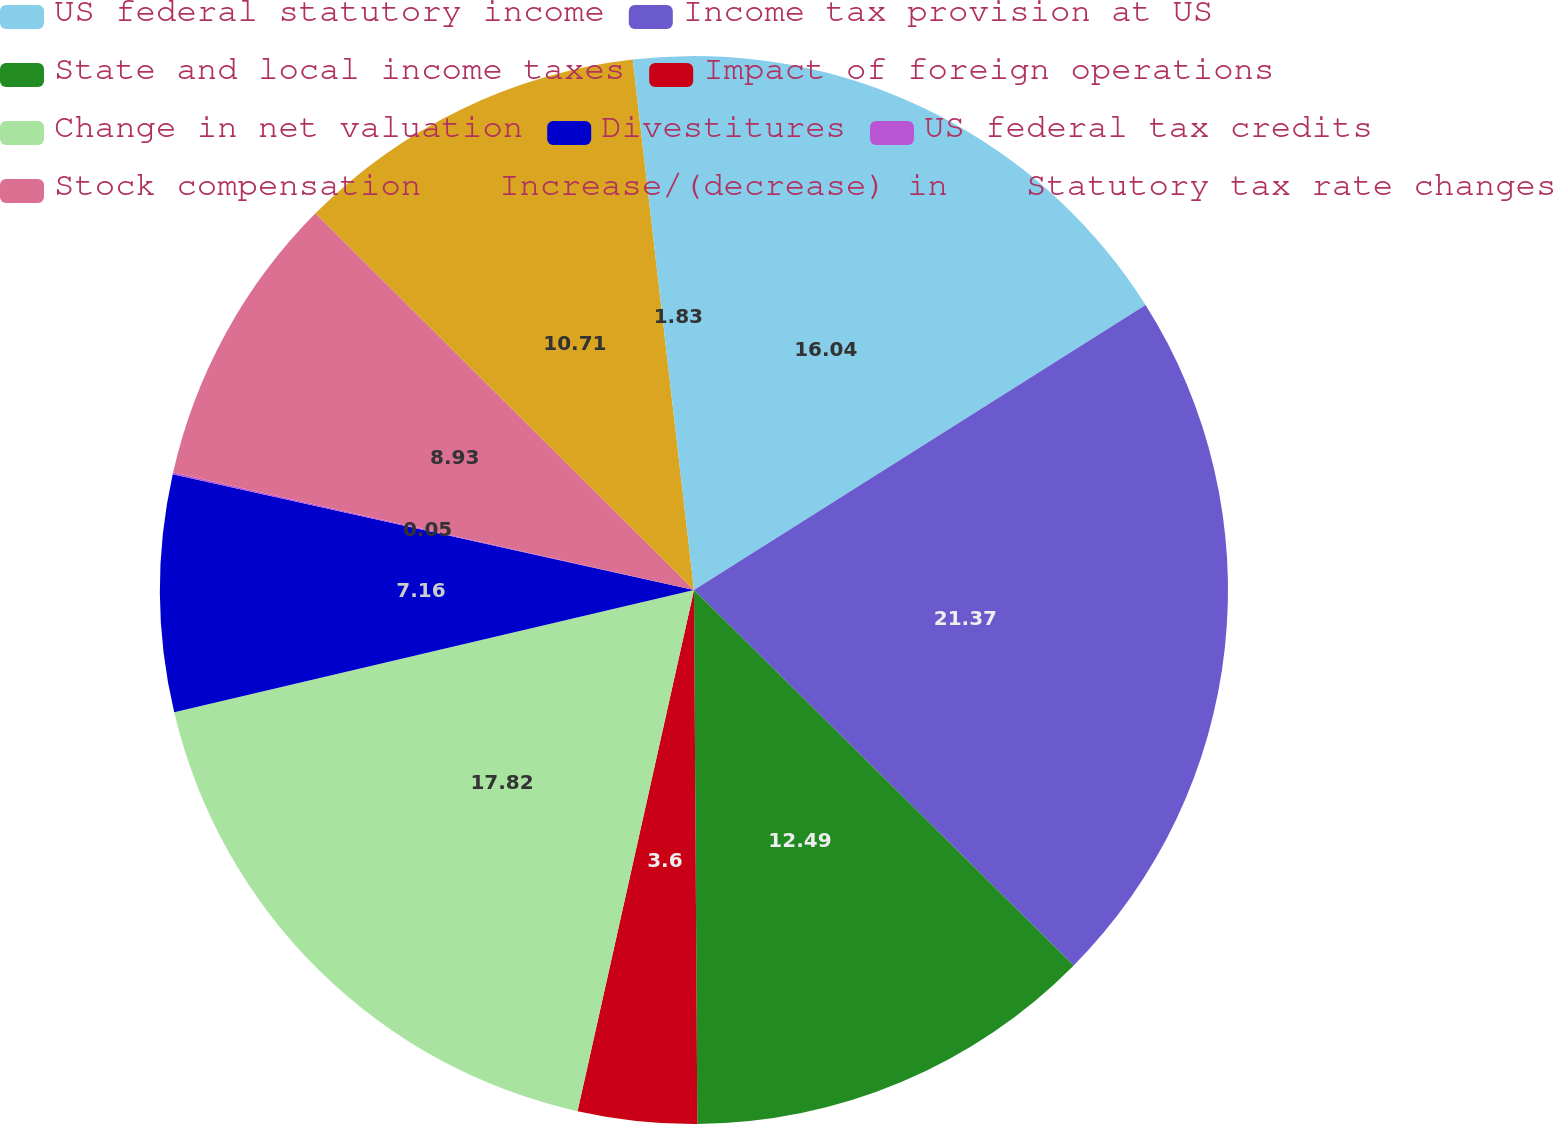<chart> <loc_0><loc_0><loc_500><loc_500><pie_chart><fcel>US federal statutory income<fcel>Income tax provision at US<fcel>State and local income taxes<fcel>Impact of foreign operations<fcel>Change in net valuation<fcel>Divestitures<fcel>US federal tax credits<fcel>Stock compensation<fcel>Increase/(decrease) in<fcel>Statutory tax rate changes<nl><fcel>16.04%<fcel>21.37%<fcel>12.49%<fcel>3.6%<fcel>17.82%<fcel>7.16%<fcel>0.05%<fcel>8.93%<fcel>10.71%<fcel>1.83%<nl></chart> 